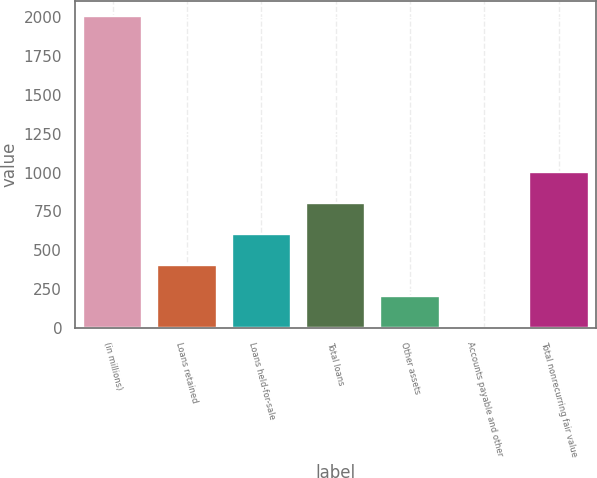Convert chart. <chart><loc_0><loc_0><loc_500><loc_500><bar_chart><fcel>(in millions)<fcel>Loans retained<fcel>Loans held-for-sale<fcel>Total loans<fcel>Other assets<fcel>Accounts payable and other<fcel>Total nonrecurring fair value<nl><fcel>2007<fcel>403<fcel>603.5<fcel>804<fcel>202.5<fcel>2<fcel>1004.5<nl></chart> 